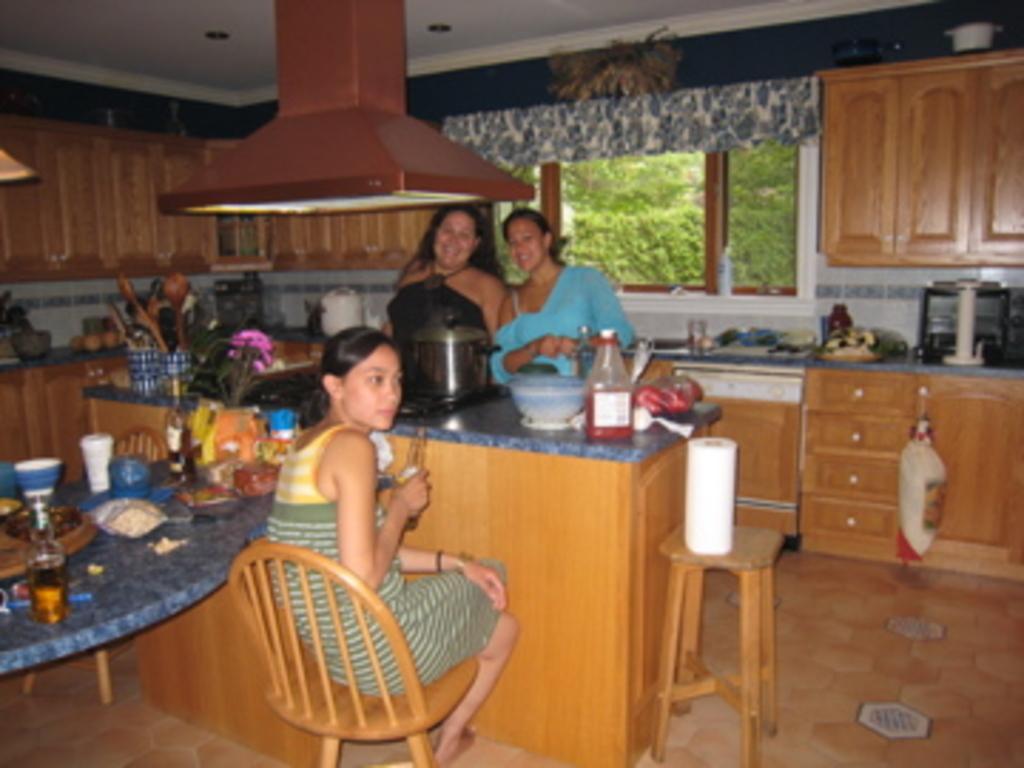Can you describe this image briefly? In this picture there are three ladies. One is sitting on the chair and the other two are standing in front the table. On the stove there is a cooker. On the table there is a bottle , bowl and other items. to the left side there is a table with bottle, bowl, glass and other items. In the background there is a window. outside the window there are trees. To the right side corner there is a cupboard. And to the bottom there are cupboard, oven and other items. 